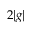<formula> <loc_0><loc_0><loc_500><loc_500>2 | g |</formula> 